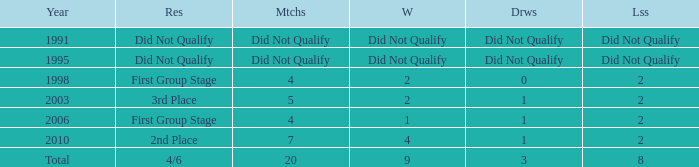How many draws were there in 2006? 1.0. 